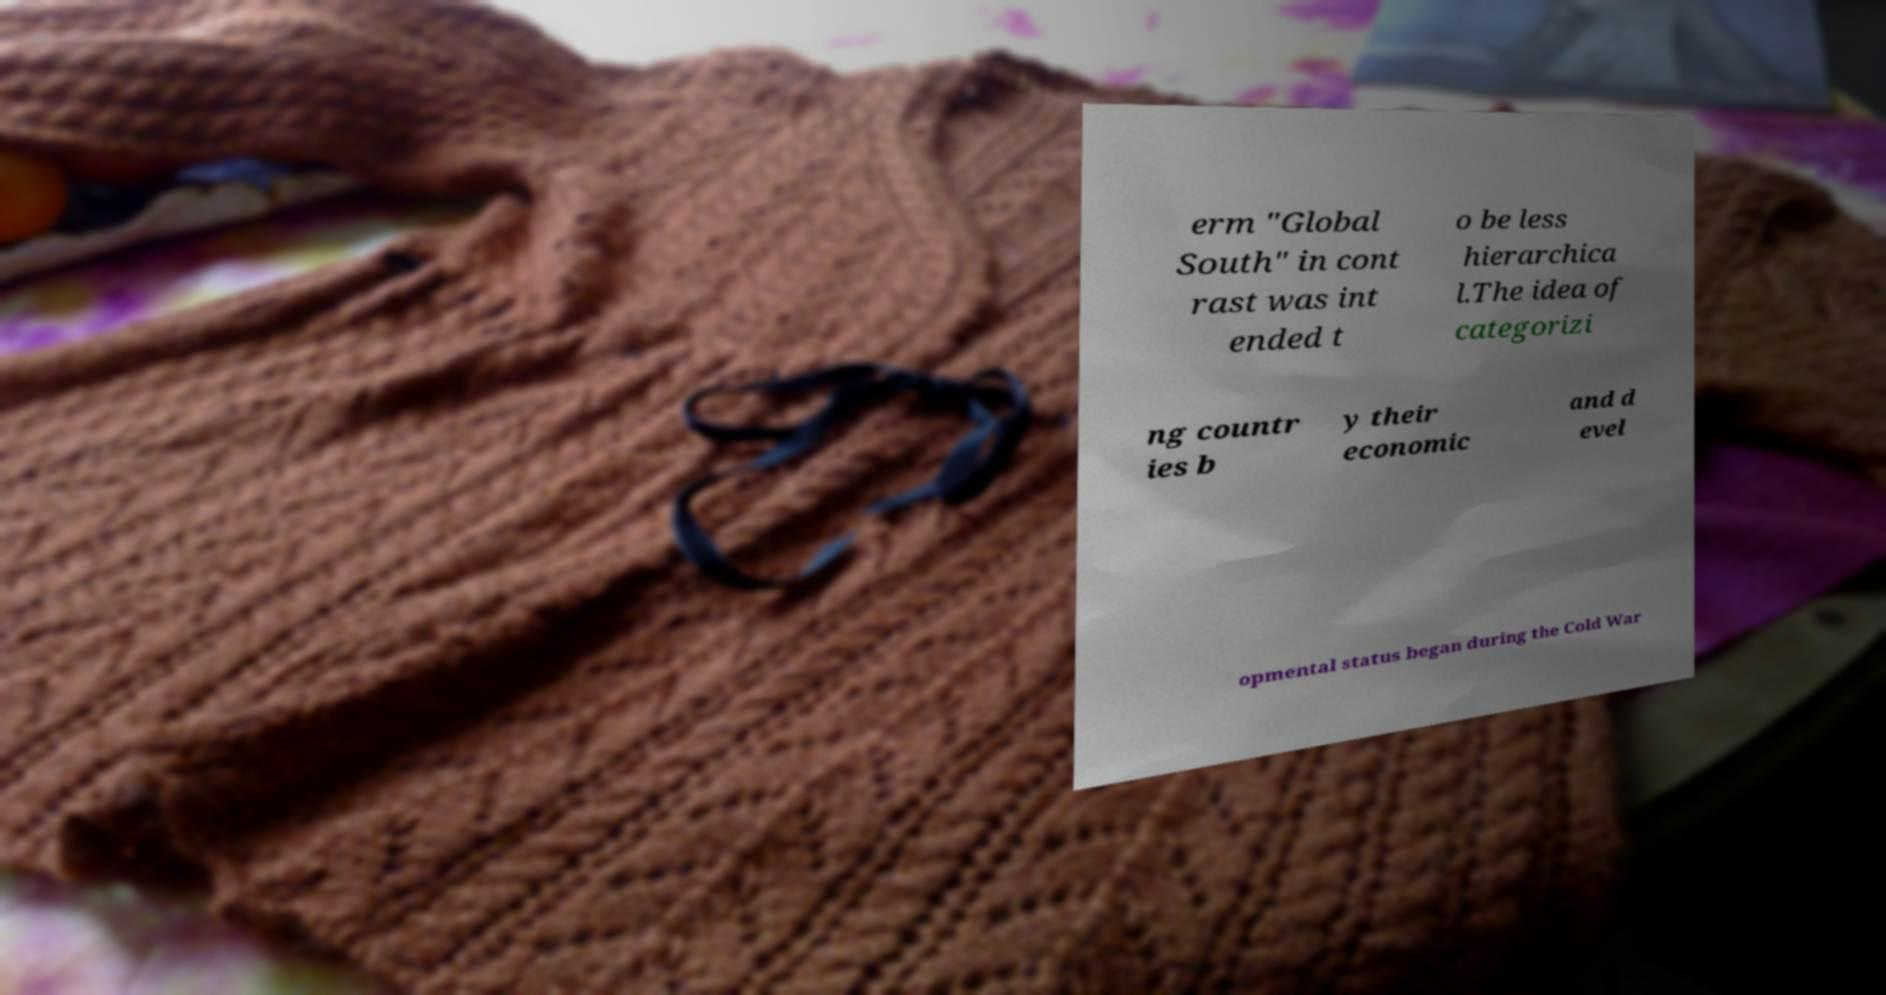What messages or text are displayed in this image? I need them in a readable, typed format. erm "Global South" in cont rast was int ended t o be less hierarchica l.The idea of categorizi ng countr ies b y their economic and d evel opmental status began during the Cold War 